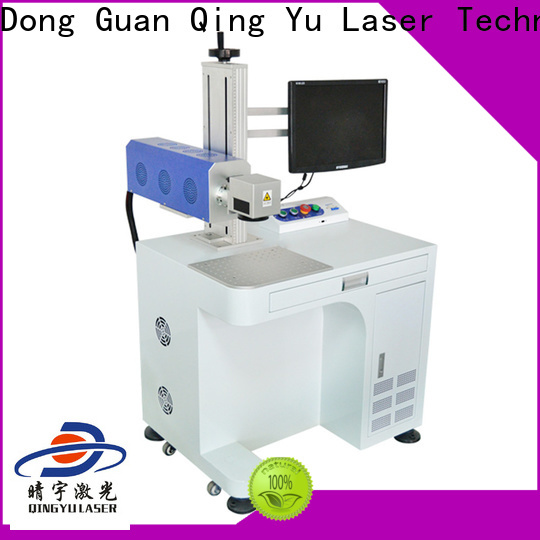Could you explain how this laser engraving machine could be used in a manufacturing plant? Certainly! This laser engraving machine offers a range of functionalities ideal for a manufacturing plant. It can be employed to engrave serial numbers, barcodes, and logos on products for traceability and branding purposes. Its precision capabilities ensure high-quality markings on various materials such as metal, plastic, and glass. The machine's adjustable settings and real-time monitoring further ensure consistency and accuracy, which is crucial for maintaining quality standards in mass production. Moreover, the mobility of the machine allows it to be easily relocated to different production lines as needed, making it a versatile asset in a dynamic manufacturing environment. 